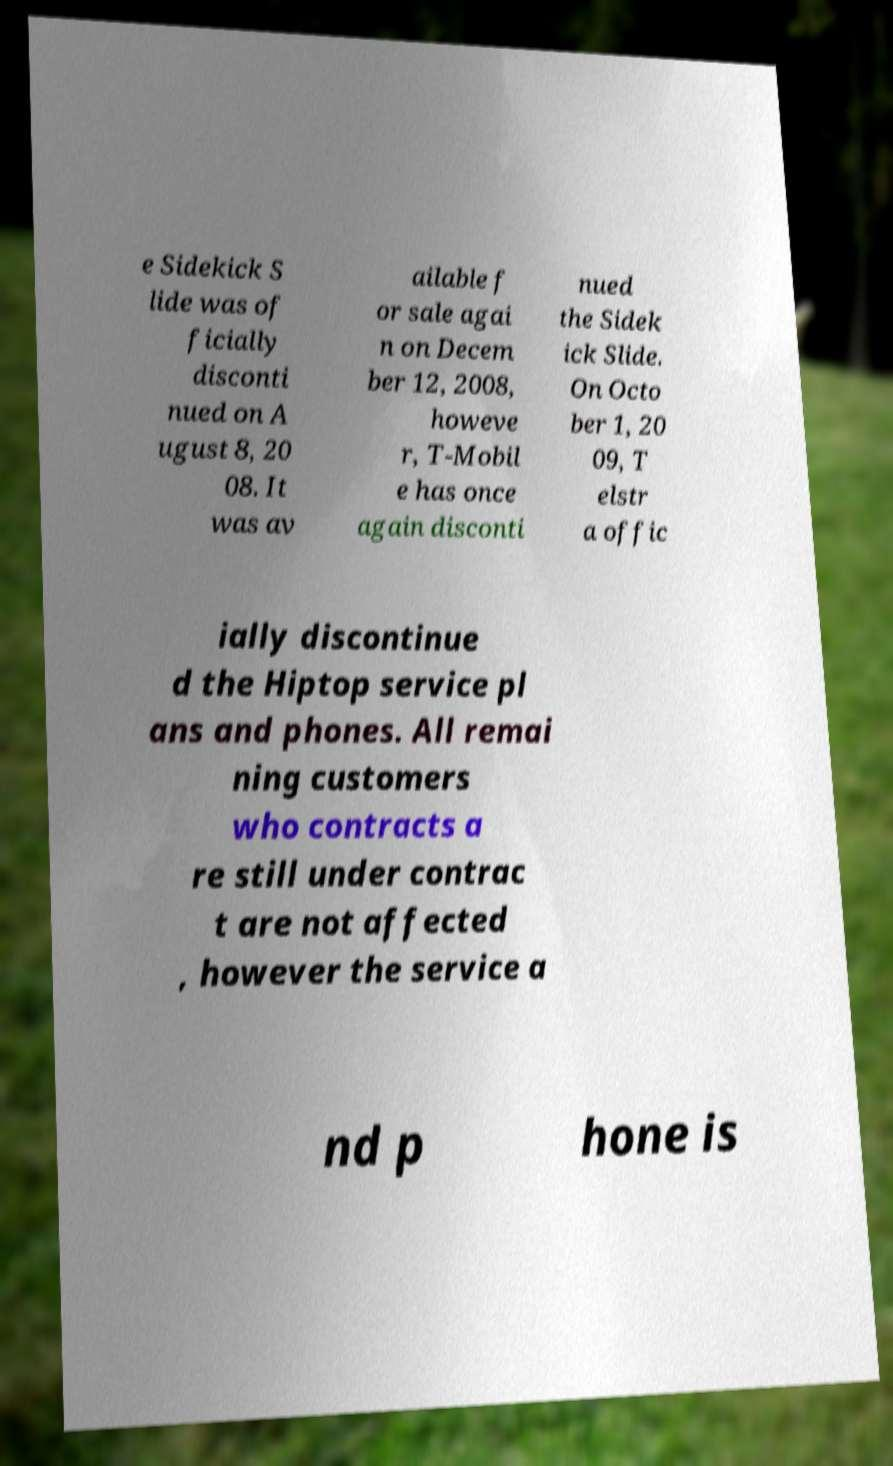For documentation purposes, I need the text within this image transcribed. Could you provide that? e Sidekick S lide was of ficially disconti nued on A ugust 8, 20 08. It was av ailable f or sale agai n on Decem ber 12, 2008, howeve r, T-Mobil e has once again disconti nued the Sidek ick Slide. On Octo ber 1, 20 09, T elstr a offic ially discontinue d the Hiptop service pl ans and phones. All remai ning customers who contracts a re still under contrac t are not affected , however the service a nd p hone is 